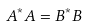<formula> <loc_0><loc_0><loc_500><loc_500>A ^ { * } A = B ^ { * } B</formula> 